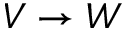<formula> <loc_0><loc_0><loc_500><loc_500>V \to W</formula> 